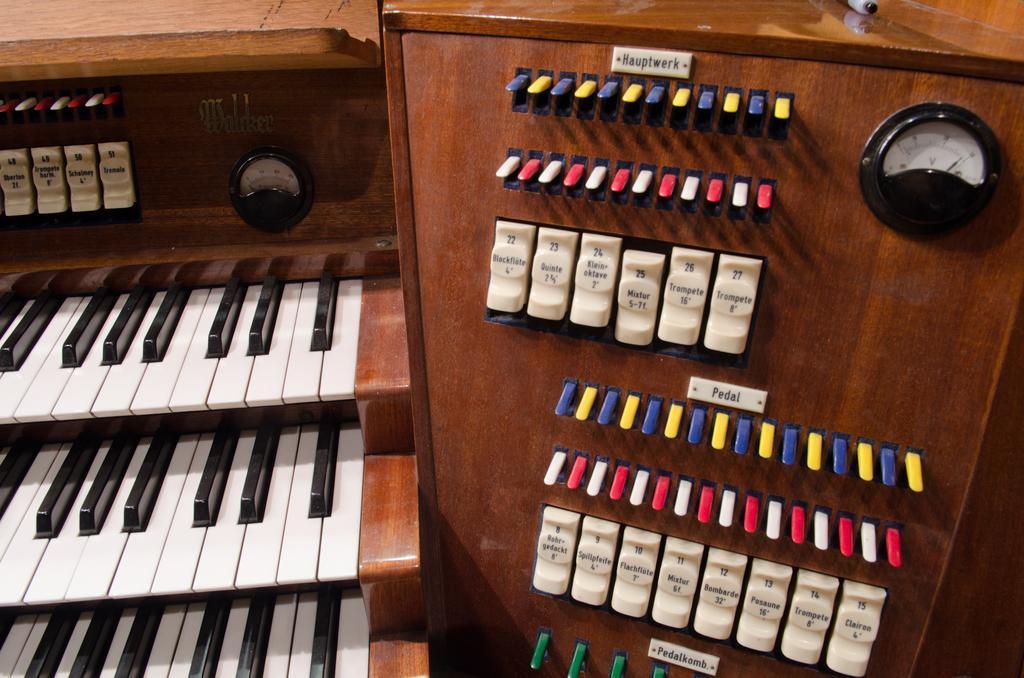Could you give a brief overview of what you see in this image? This looks like a piano with a meters attached to the device. These are the keys which are used to control the device. 